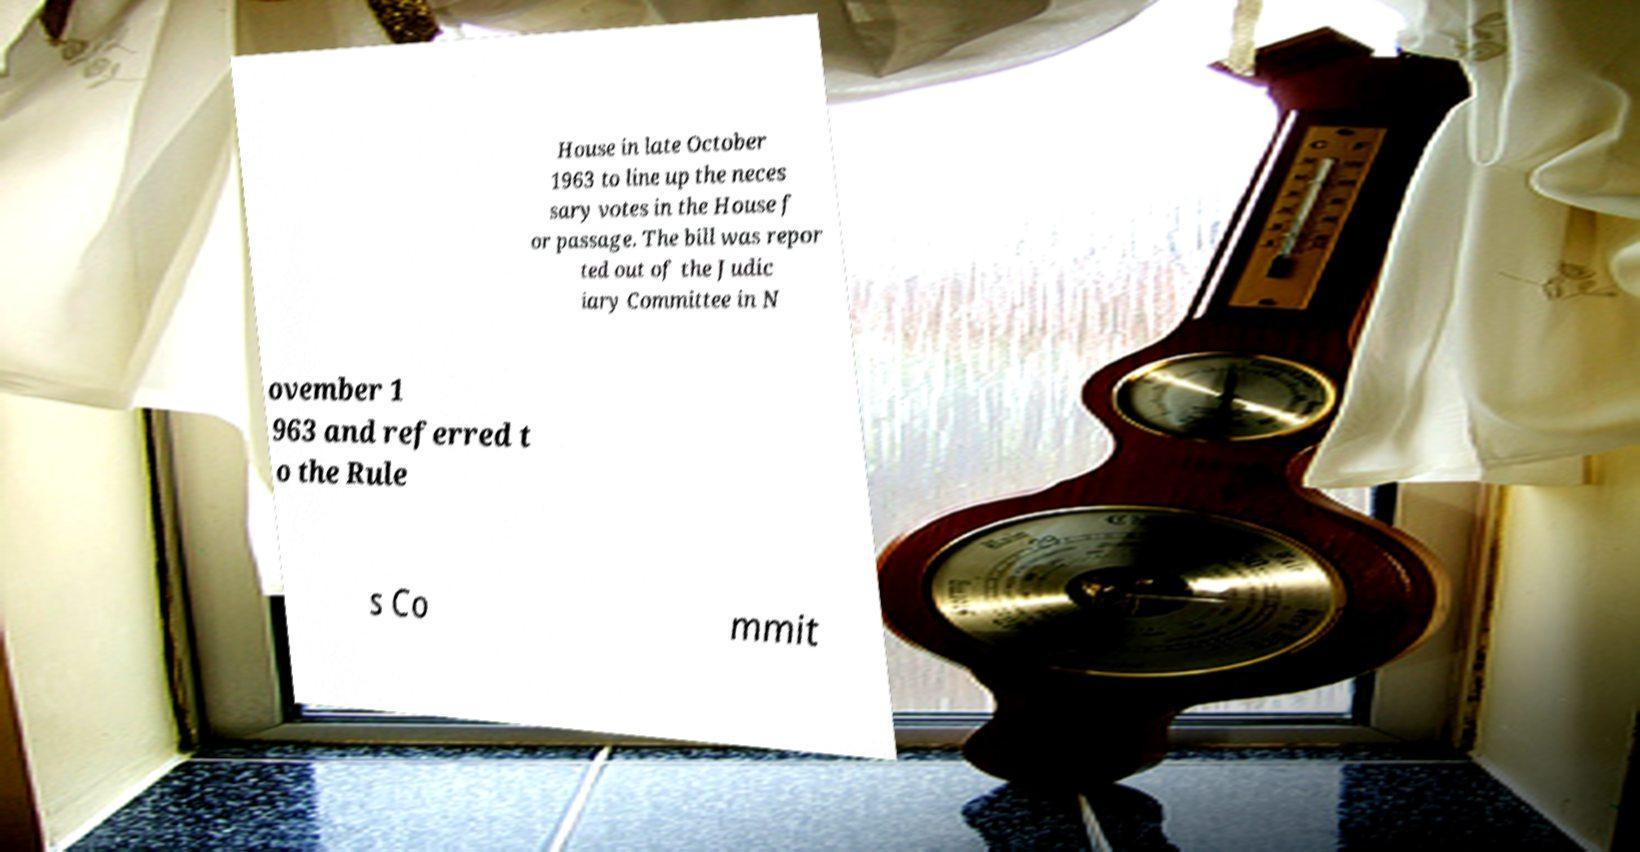Please identify and transcribe the text found in this image. House in late October 1963 to line up the neces sary votes in the House f or passage. The bill was repor ted out of the Judic iary Committee in N ovember 1 963 and referred t o the Rule s Co mmit 